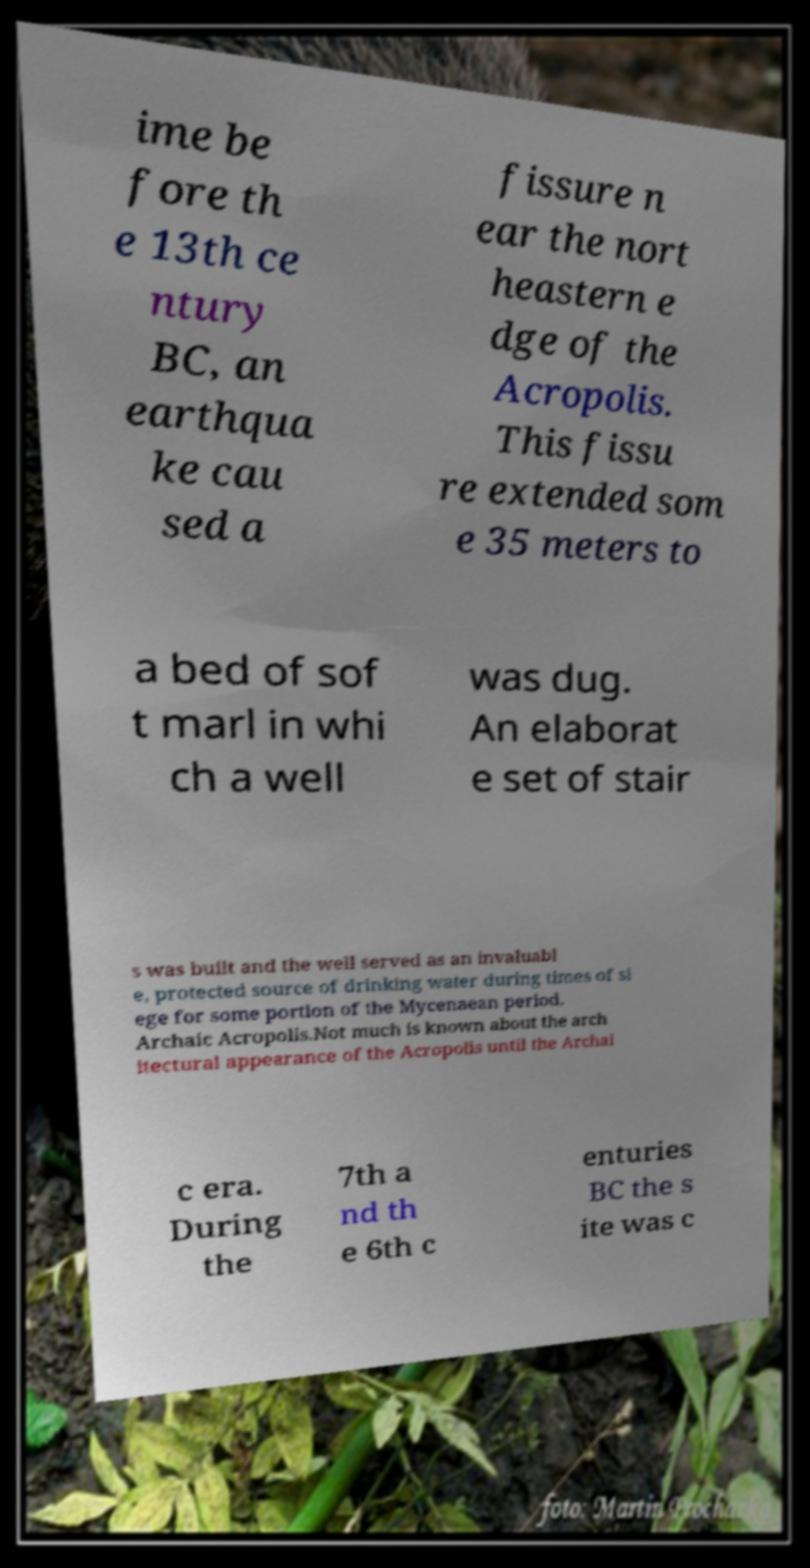What messages or text are displayed in this image? I need them in a readable, typed format. ime be fore th e 13th ce ntury BC, an earthqua ke cau sed a fissure n ear the nort heastern e dge of the Acropolis. This fissu re extended som e 35 meters to a bed of sof t marl in whi ch a well was dug. An elaborat e set of stair s was built and the well served as an invaluabl e, protected source of drinking water during times of si ege for some portion of the Mycenaean period. Archaic Acropolis.Not much is known about the arch itectural appearance of the Acropolis until the Archai c era. During the 7th a nd th e 6th c enturies BC the s ite was c 